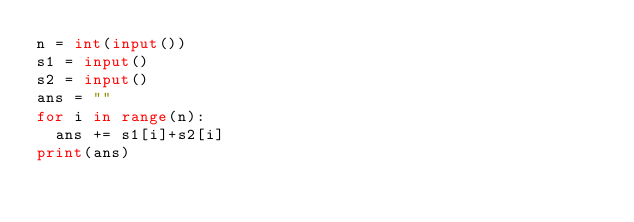<code> <loc_0><loc_0><loc_500><loc_500><_Python_>n = int(input())
s1 = input()
s2 = input()
ans = ""
for i in range(n):
  ans += s1[i]+s2[i]
print(ans)</code> 